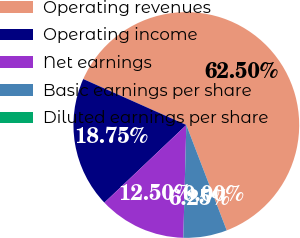Convert chart. <chart><loc_0><loc_0><loc_500><loc_500><pie_chart><fcel>Operating revenues<fcel>Operating income<fcel>Net earnings<fcel>Basic earnings per share<fcel>Diluted earnings per share<nl><fcel>62.5%<fcel>18.75%<fcel>12.5%<fcel>6.25%<fcel>0.0%<nl></chart> 